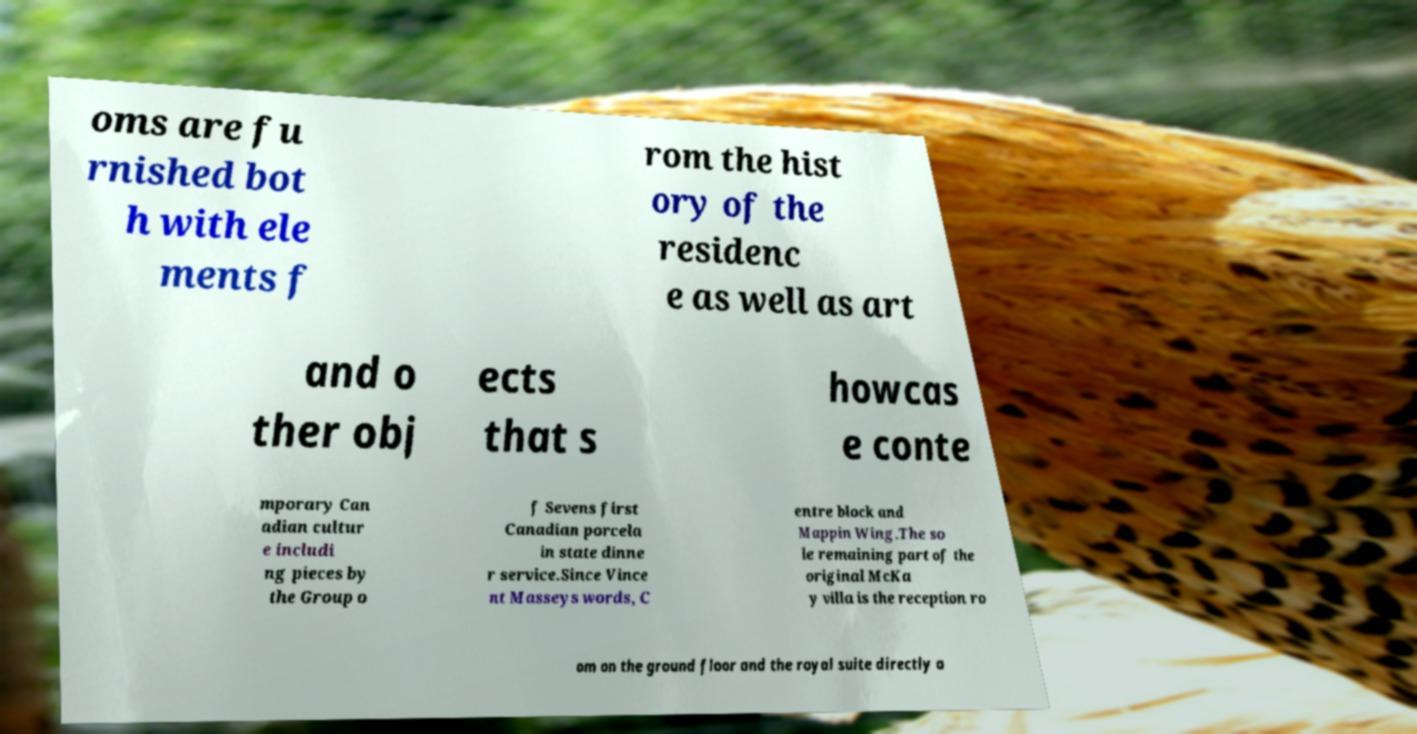What messages or text are displayed in this image? I need them in a readable, typed format. oms are fu rnished bot h with ele ments f rom the hist ory of the residenc e as well as art and o ther obj ects that s howcas e conte mporary Can adian cultur e includi ng pieces by the Group o f Sevens first Canadian porcela in state dinne r service.Since Vince nt Masseys words, C entre block and Mappin Wing.The so le remaining part of the original McKa y villa is the reception ro om on the ground floor and the royal suite directly a 